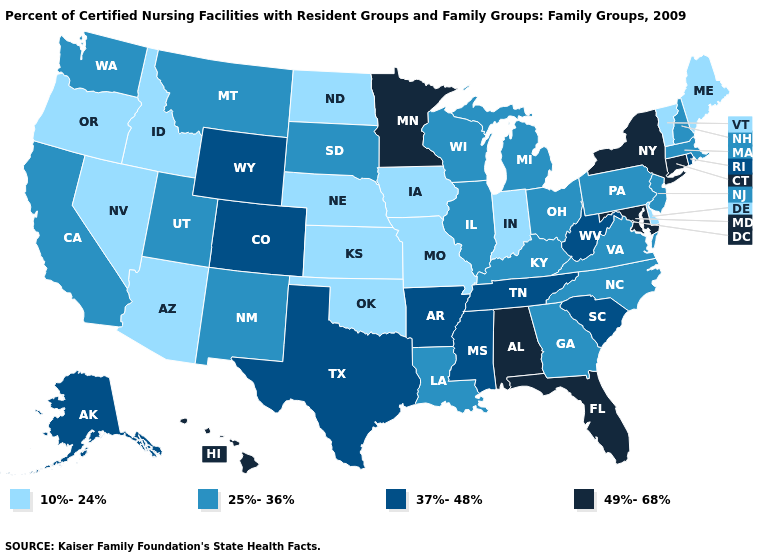What is the value of Alabama?
Answer briefly. 49%-68%. Among the states that border Texas , does Oklahoma have the highest value?
Be succinct. No. Name the states that have a value in the range 25%-36%?
Quick response, please. California, Georgia, Illinois, Kentucky, Louisiana, Massachusetts, Michigan, Montana, New Hampshire, New Jersey, New Mexico, North Carolina, Ohio, Pennsylvania, South Dakota, Utah, Virginia, Washington, Wisconsin. How many symbols are there in the legend?
Give a very brief answer. 4. Which states have the lowest value in the South?
Write a very short answer. Delaware, Oklahoma. What is the lowest value in the USA?
Give a very brief answer. 10%-24%. What is the value of Vermont?
Quick response, please. 10%-24%. Is the legend a continuous bar?
Give a very brief answer. No. What is the value of Missouri?
Keep it brief. 10%-24%. How many symbols are there in the legend?
Concise answer only. 4. Among the states that border Washington , which have the lowest value?
Be succinct. Idaho, Oregon. Does Maine have the lowest value in the USA?
Keep it brief. Yes. Which states have the highest value in the USA?
Short answer required. Alabama, Connecticut, Florida, Hawaii, Maryland, Minnesota, New York. Among the states that border Oklahoma , does Missouri have the lowest value?
Short answer required. Yes. Name the states that have a value in the range 25%-36%?
Write a very short answer. California, Georgia, Illinois, Kentucky, Louisiana, Massachusetts, Michigan, Montana, New Hampshire, New Jersey, New Mexico, North Carolina, Ohio, Pennsylvania, South Dakota, Utah, Virginia, Washington, Wisconsin. 